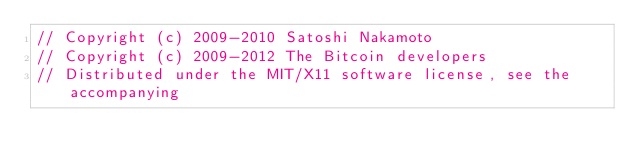<code> <loc_0><loc_0><loc_500><loc_500><_C++_>// Copyright (c) 2009-2010 Satoshi Nakamoto
// Copyright (c) 2009-2012 The Bitcoin developers
// Distributed under the MIT/X11 software license, see the accompanying</code> 